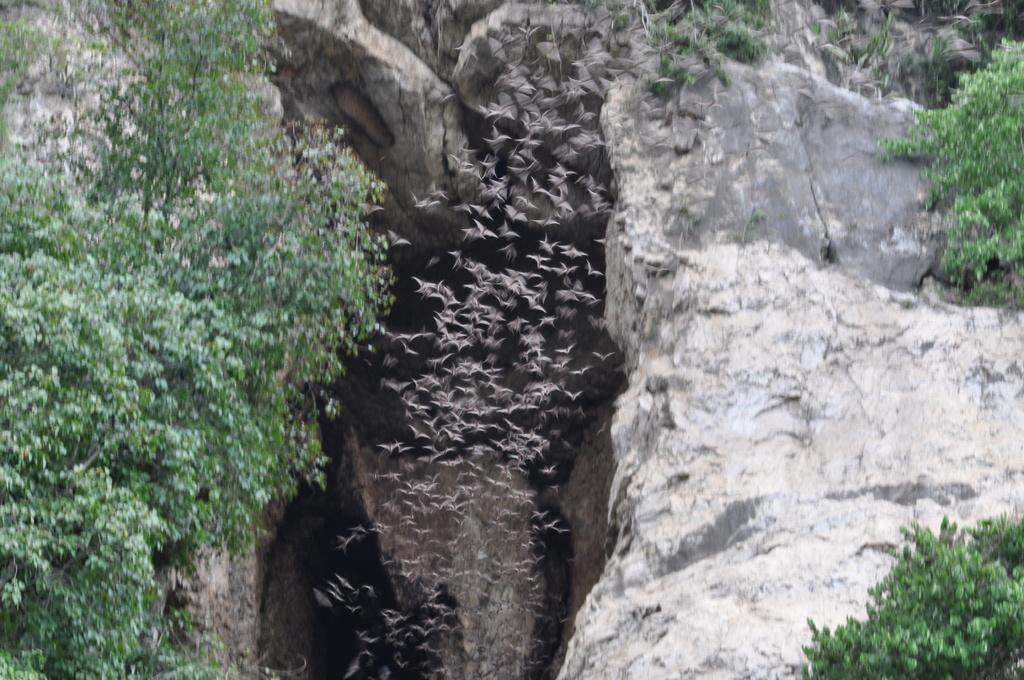What type of vegetation is visible in the image? There are trees in the image. What other natural elements can be seen in the image? There are rocks in the image. What animals are present in the image? Birds are flying in the image. What type of doll can be seen sitting on the low brick wall in the image? There is no doll or brick wall present in the image; it features trees, rocks, and flying birds. 